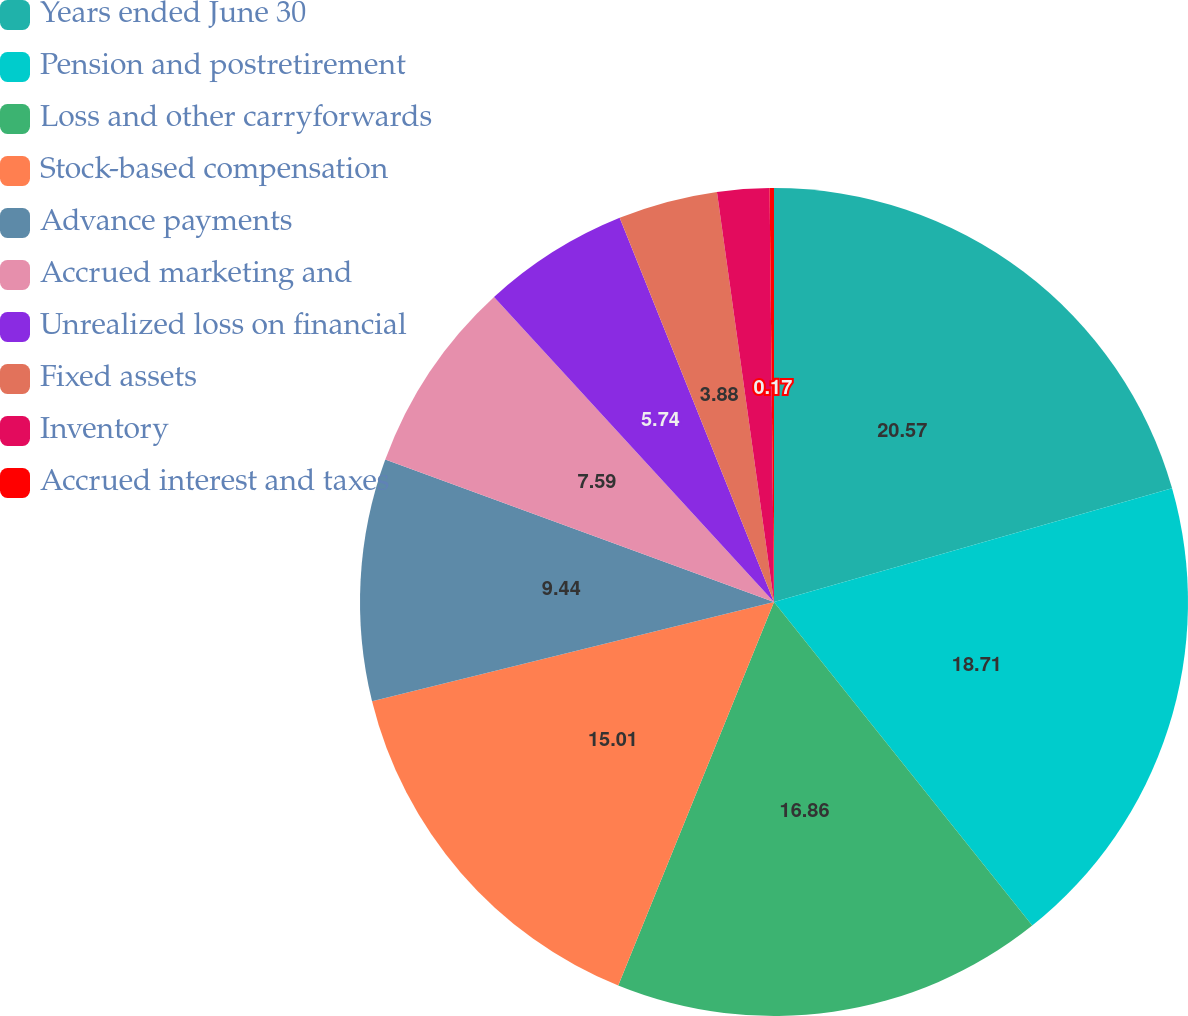<chart> <loc_0><loc_0><loc_500><loc_500><pie_chart><fcel>Years ended June 30<fcel>Pension and postretirement<fcel>Loss and other carryforwards<fcel>Stock-based compensation<fcel>Advance payments<fcel>Accrued marketing and<fcel>Unrealized loss on financial<fcel>Fixed assets<fcel>Inventory<fcel>Accrued interest and taxes<nl><fcel>20.57%<fcel>18.71%<fcel>16.86%<fcel>15.01%<fcel>9.44%<fcel>7.59%<fcel>5.74%<fcel>3.88%<fcel>2.03%<fcel>0.17%<nl></chart> 